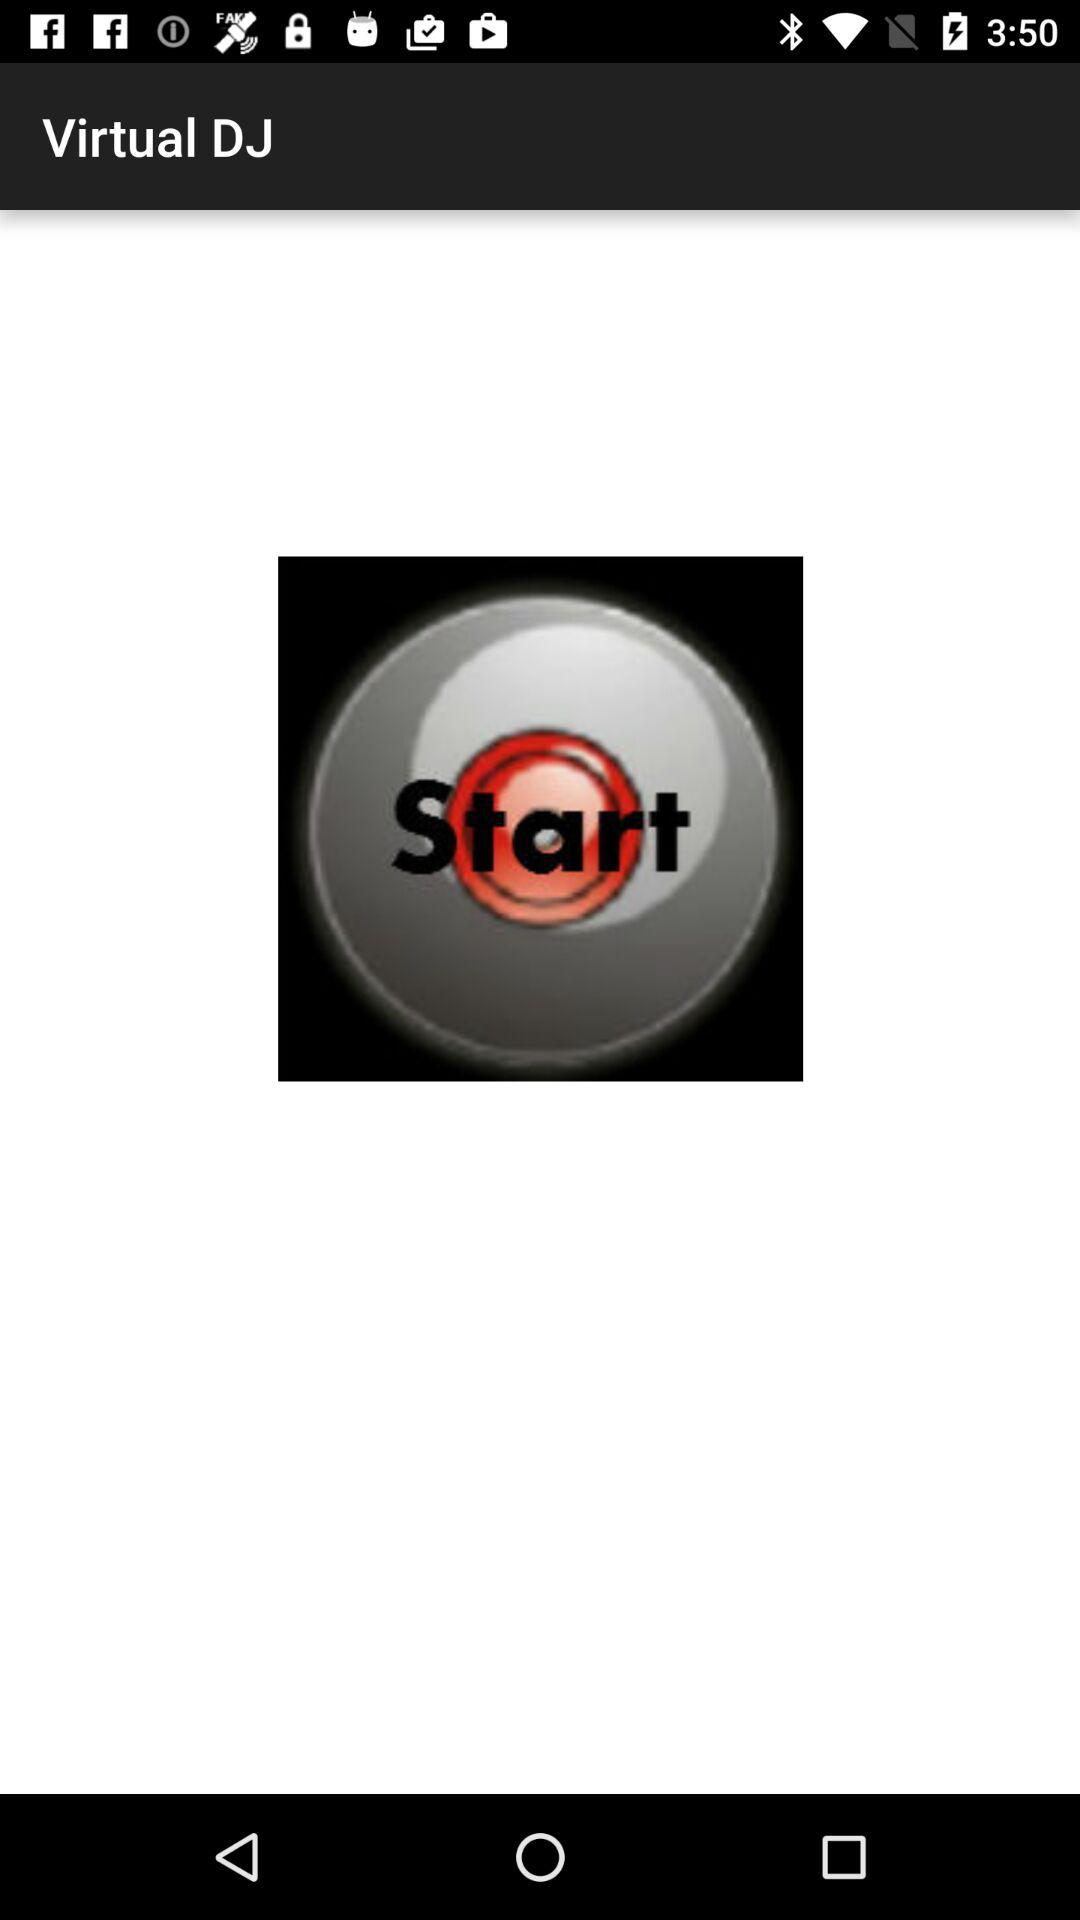What is the application name? The application name is "Virtual DJ". 